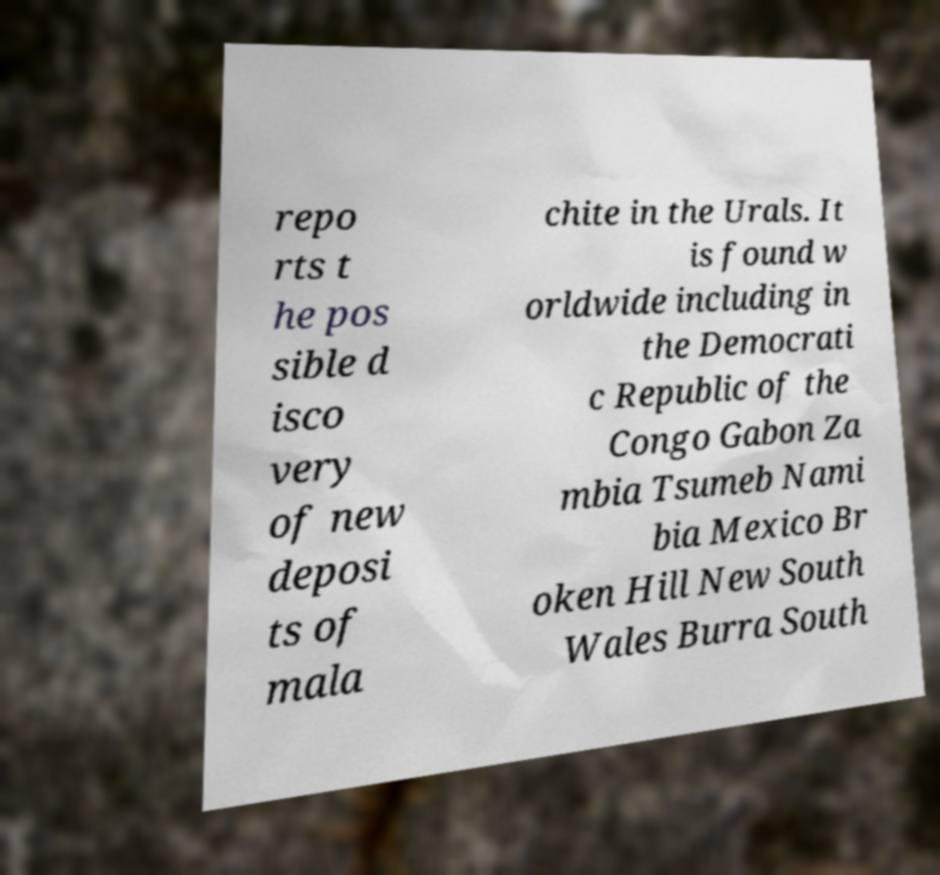Can you accurately transcribe the text from the provided image for me? repo rts t he pos sible d isco very of new deposi ts of mala chite in the Urals. It is found w orldwide including in the Democrati c Republic of the Congo Gabon Za mbia Tsumeb Nami bia Mexico Br oken Hill New South Wales Burra South 